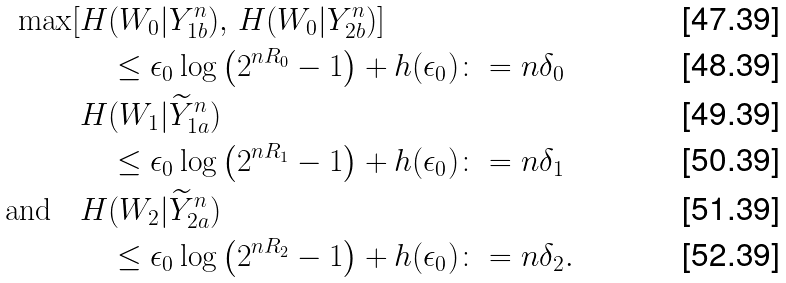Convert formula to latex. <formula><loc_0><loc_0><loc_500><loc_500>\max [ H & ( W _ { 0 } | Y _ { 1 b } ^ { n } ) , \, H ( W _ { 0 } | Y _ { 2 b } ^ { n } ) ] \\ & \leq \epsilon _ { 0 } \log \left ( 2 ^ { n R _ { 0 } } - 1 \right ) + h ( \epsilon _ { 0 } ) \colon = n \delta _ { 0 } \\ H & ( W _ { 1 } | \widetilde { Y } _ { 1 a } ^ { n } ) \\ & \leq \epsilon _ { 0 } \log \left ( 2 ^ { n R _ { 1 } } - 1 \right ) + h ( \epsilon _ { 0 } ) \colon = n \delta _ { 1 } \\ \text {and} \quad H & ( W _ { 2 } | \widetilde { Y } _ { 2 a } ^ { n } ) \\ & \leq \epsilon _ { 0 } \log \left ( 2 ^ { n R _ { 2 } } - 1 \right ) + h ( \epsilon _ { 0 } ) \colon = n \delta _ { 2 } .</formula> 